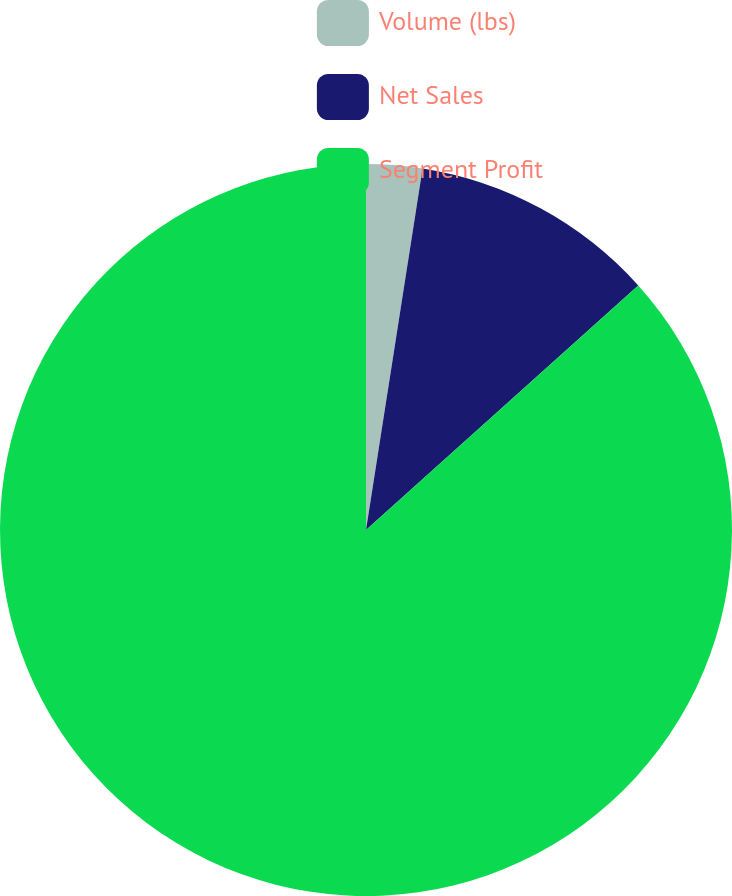<chart> <loc_0><loc_0><loc_500><loc_500><pie_chart><fcel>Volume (lbs)<fcel>Net Sales<fcel>Segment Profit<nl><fcel>2.47%<fcel>10.88%<fcel>86.65%<nl></chart> 